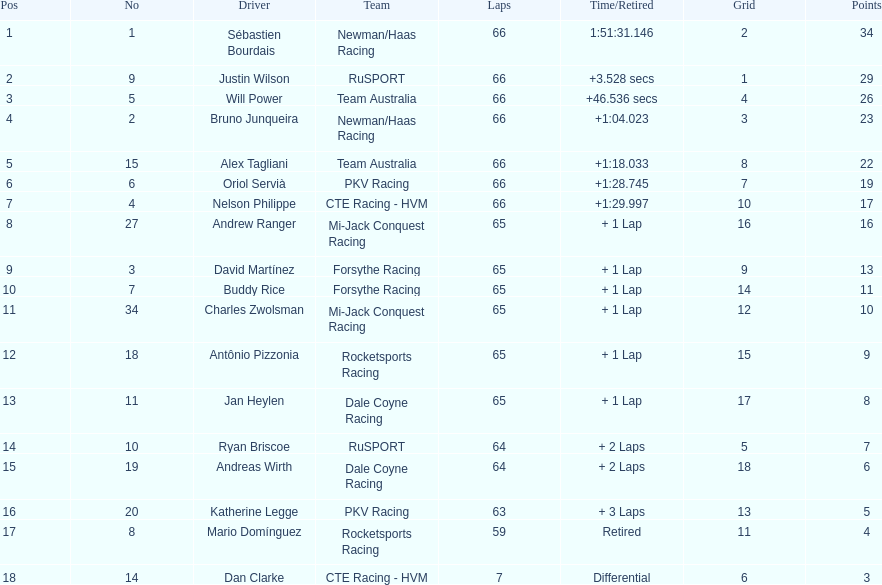What is the number of laps dan clarke completed? 7. 